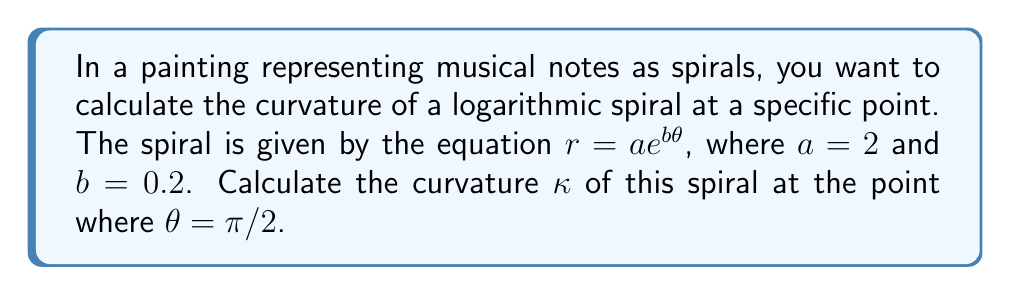Can you solve this math problem? To calculate the curvature of a logarithmic spiral, we'll follow these steps:

1) The general formula for the curvature of a plane curve in polar coordinates is:

   $$\kappa = \frac{|r^2 + 2(r')^2 - rr''|}{(r^2 + (r')^2)^{3/2}}$$

2) For a logarithmic spiral $r = ae^{b\theta}$, we need to find $r'$ and $r''$:
   
   $r' = abe^{b\theta}$
   $r'' = ab^2e^{b\theta}$

3) Substituting these into the curvature formula:

   $$\kappa = \frac{|(ae^{b\theta})^2 + 2(abe^{b\theta})^2 - (ae^{b\theta})(ab^2e^{b\theta})|}{((ae^{b\theta})^2 + (abe^{b\theta})^2)^{3/2}}$$

4) Simplify:

   $$\kappa = \frac{|a^2e^{2b\theta}(1 + 2b^2 - b^2)|}{a^3e^{3b\theta}(1 + b^2)^{3/2}}$$

5) Further simplify:

   $$\kappa = \frac{|1 + b^2|}{ae^{b\theta}(1 + b^2)^{3/2}}$$

6) Now, substitute the given values: $a = 2$, $b = 0.2$, and $\theta = \pi/2$:

   $$\kappa = \frac{|1 + 0.2^2|}{2e^{0.2(\pi/2)}(1 + 0.2^2)^{3/2}}$$

7) Calculate:

   $$\kappa = \frac{1.04}{2e^{0.1\pi}(1.04)^{3/2}} \approx 0.3062$$
Answer: $\kappa \approx 0.3062$ 